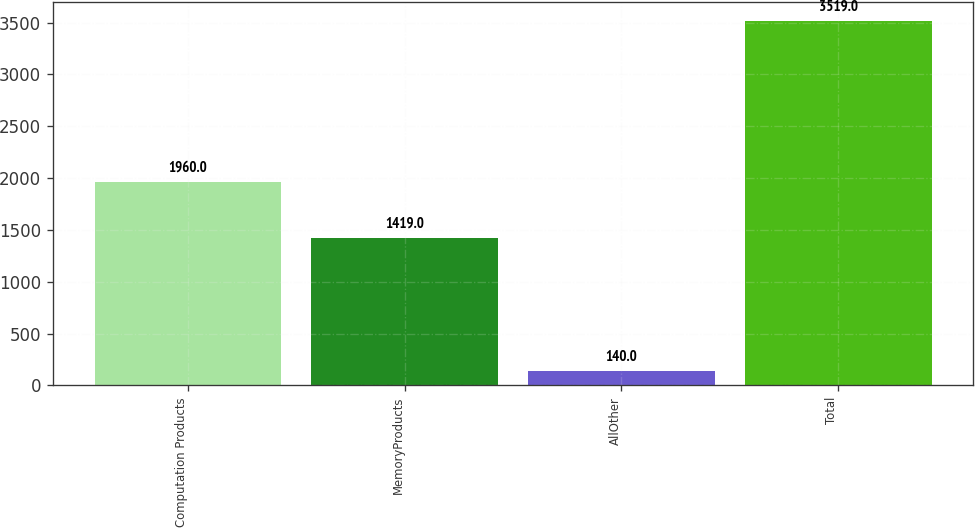<chart> <loc_0><loc_0><loc_500><loc_500><bar_chart><fcel>Computation Products<fcel>MemoryProducts<fcel>AllOther<fcel>Total<nl><fcel>1960<fcel>1419<fcel>140<fcel>3519<nl></chart> 